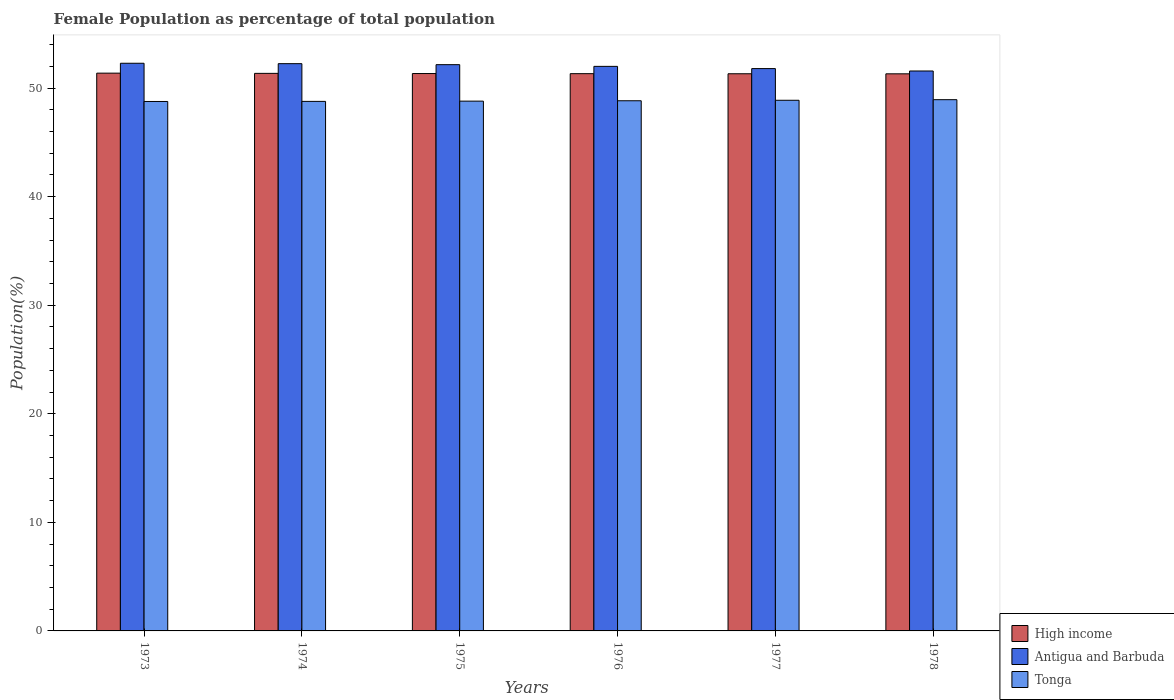How many groups of bars are there?
Give a very brief answer. 6. How many bars are there on the 2nd tick from the left?
Your answer should be compact. 3. What is the label of the 2nd group of bars from the left?
Your answer should be compact. 1974. In how many cases, is the number of bars for a given year not equal to the number of legend labels?
Your answer should be very brief. 0. What is the female population in in High income in 1975?
Provide a succinct answer. 51.34. Across all years, what is the maximum female population in in Antigua and Barbuda?
Give a very brief answer. 52.28. Across all years, what is the minimum female population in in High income?
Ensure brevity in your answer.  51.31. In which year was the female population in in High income maximum?
Make the answer very short. 1973. In which year was the female population in in Tonga minimum?
Give a very brief answer. 1973. What is the total female population in in High income in the graph?
Ensure brevity in your answer.  308.02. What is the difference between the female population in in High income in 1973 and that in 1974?
Ensure brevity in your answer.  0.02. What is the difference between the female population in in Antigua and Barbuda in 1977 and the female population in in Tonga in 1975?
Your answer should be compact. 3. What is the average female population in in Antigua and Barbuda per year?
Keep it short and to the point. 52.01. In the year 1978, what is the difference between the female population in in Antigua and Barbuda and female population in in Tonga?
Ensure brevity in your answer.  2.64. In how many years, is the female population in in Antigua and Barbuda greater than 4 %?
Offer a terse response. 6. What is the ratio of the female population in in Tonga in 1973 to that in 1977?
Your answer should be compact. 1. Is the female population in in High income in 1973 less than that in 1976?
Provide a short and direct response. No. Is the difference between the female population in in Antigua and Barbuda in 1976 and 1978 greater than the difference between the female population in in Tonga in 1976 and 1978?
Give a very brief answer. Yes. What is the difference between the highest and the second highest female population in in High income?
Keep it short and to the point. 0.02. What is the difference between the highest and the lowest female population in in High income?
Keep it short and to the point. 0.06. In how many years, is the female population in in High income greater than the average female population in in High income taken over all years?
Provide a succinct answer. 3. Is the sum of the female population in in Antigua and Barbuda in 1974 and 1978 greater than the maximum female population in in High income across all years?
Ensure brevity in your answer.  Yes. What does the 2nd bar from the left in 1975 represents?
Offer a terse response. Antigua and Barbuda. What does the 2nd bar from the right in 1978 represents?
Ensure brevity in your answer.  Antigua and Barbuda. Is it the case that in every year, the sum of the female population in in Antigua and Barbuda and female population in in Tonga is greater than the female population in in High income?
Provide a succinct answer. Yes. Are the values on the major ticks of Y-axis written in scientific E-notation?
Offer a terse response. No. Does the graph contain any zero values?
Offer a very short reply. No. Does the graph contain grids?
Offer a very short reply. No. Where does the legend appear in the graph?
Ensure brevity in your answer.  Bottom right. How many legend labels are there?
Provide a succinct answer. 3. How are the legend labels stacked?
Your answer should be compact. Vertical. What is the title of the graph?
Ensure brevity in your answer.  Female Population as percentage of total population. Does "Portugal" appear as one of the legend labels in the graph?
Offer a very short reply. No. What is the label or title of the X-axis?
Offer a very short reply. Years. What is the label or title of the Y-axis?
Offer a terse response. Population(%). What is the Population(%) in High income in 1973?
Provide a succinct answer. 51.37. What is the Population(%) of Antigua and Barbuda in 1973?
Ensure brevity in your answer.  52.28. What is the Population(%) of Tonga in 1973?
Make the answer very short. 48.76. What is the Population(%) in High income in 1974?
Keep it short and to the point. 51.35. What is the Population(%) in Antigua and Barbuda in 1974?
Offer a terse response. 52.25. What is the Population(%) of Tonga in 1974?
Your response must be concise. 48.77. What is the Population(%) in High income in 1975?
Offer a terse response. 51.34. What is the Population(%) in Antigua and Barbuda in 1975?
Offer a terse response. 52.16. What is the Population(%) of Tonga in 1975?
Ensure brevity in your answer.  48.8. What is the Population(%) of High income in 1976?
Give a very brief answer. 51.33. What is the Population(%) in Antigua and Barbuda in 1976?
Keep it short and to the point. 52. What is the Population(%) in Tonga in 1976?
Provide a short and direct response. 48.83. What is the Population(%) in High income in 1977?
Keep it short and to the point. 51.32. What is the Population(%) in Antigua and Barbuda in 1977?
Provide a short and direct response. 51.79. What is the Population(%) in Tonga in 1977?
Provide a short and direct response. 48.87. What is the Population(%) in High income in 1978?
Give a very brief answer. 51.31. What is the Population(%) in Antigua and Barbuda in 1978?
Your answer should be compact. 51.57. What is the Population(%) in Tonga in 1978?
Your response must be concise. 48.93. Across all years, what is the maximum Population(%) in High income?
Give a very brief answer. 51.37. Across all years, what is the maximum Population(%) of Antigua and Barbuda?
Offer a terse response. 52.28. Across all years, what is the maximum Population(%) in Tonga?
Provide a short and direct response. 48.93. Across all years, what is the minimum Population(%) of High income?
Provide a short and direct response. 51.31. Across all years, what is the minimum Population(%) in Antigua and Barbuda?
Your answer should be very brief. 51.57. Across all years, what is the minimum Population(%) in Tonga?
Give a very brief answer. 48.76. What is the total Population(%) in High income in the graph?
Give a very brief answer. 308.02. What is the total Population(%) of Antigua and Barbuda in the graph?
Offer a terse response. 312.05. What is the total Population(%) in Tonga in the graph?
Your response must be concise. 292.97. What is the difference between the Population(%) in High income in 1973 and that in 1974?
Provide a succinct answer. 0.02. What is the difference between the Population(%) of Antigua and Barbuda in 1973 and that in 1974?
Offer a very short reply. 0.04. What is the difference between the Population(%) of Tonga in 1973 and that in 1974?
Offer a very short reply. -0.01. What is the difference between the Population(%) in High income in 1973 and that in 1975?
Your response must be concise. 0.04. What is the difference between the Population(%) of Antigua and Barbuda in 1973 and that in 1975?
Offer a terse response. 0.13. What is the difference between the Population(%) of Tonga in 1973 and that in 1975?
Provide a short and direct response. -0.03. What is the difference between the Population(%) of High income in 1973 and that in 1976?
Keep it short and to the point. 0.05. What is the difference between the Population(%) in Antigua and Barbuda in 1973 and that in 1976?
Offer a very short reply. 0.29. What is the difference between the Population(%) of Tonga in 1973 and that in 1976?
Your response must be concise. -0.07. What is the difference between the Population(%) in High income in 1973 and that in 1977?
Keep it short and to the point. 0.06. What is the difference between the Population(%) in Antigua and Barbuda in 1973 and that in 1977?
Offer a very short reply. 0.49. What is the difference between the Population(%) in Tonga in 1973 and that in 1977?
Provide a succinct answer. -0.11. What is the difference between the Population(%) of High income in 1973 and that in 1978?
Your response must be concise. 0.06. What is the difference between the Population(%) in Antigua and Barbuda in 1973 and that in 1978?
Ensure brevity in your answer.  0.71. What is the difference between the Population(%) of Tonga in 1973 and that in 1978?
Offer a very short reply. -0.16. What is the difference between the Population(%) in High income in 1974 and that in 1975?
Make the answer very short. 0.02. What is the difference between the Population(%) in Antigua and Barbuda in 1974 and that in 1975?
Offer a very short reply. 0.09. What is the difference between the Population(%) in Tonga in 1974 and that in 1975?
Your answer should be compact. -0.02. What is the difference between the Population(%) of High income in 1974 and that in 1976?
Your answer should be compact. 0.03. What is the difference between the Population(%) in Antigua and Barbuda in 1974 and that in 1976?
Your response must be concise. 0.25. What is the difference between the Population(%) in Tonga in 1974 and that in 1976?
Keep it short and to the point. -0.06. What is the difference between the Population(%) of High income in 1974 and that in 1977?
Your response must be concise. 0.04. What is the difference between the Population(%) in Antigua and Barbuda in 1974 and that in 1977?
Make the answer very short. 0.45. What is the difference between the Population(%) of Tonga in 1974 and that in 1977?
Keep it short and to the point. -0.1. What is the difference between the Population(%) in High income in 1974 and that in 1978?
Your response must be concise. 0.04. What is the difference between the Population(%) of Antigua and Barbuda in 1974 and that in 1978?
Your answer should be compact. 0.67. What is the difference between the Population(%) of Tonga in 1974 and that in 1978?
Offer a terse response. -0.16. What is the difference between the Population(%) of High income in 1975 and that in 1976?
Your answer should be compact. 0.01. What is the difference between the Population(%) of Antigua and Barbuda in 1975 and that in 1976?
Offer a terse response. 0.16. What is the difference between the Population(%) of Tonga in 1975 and that in 1976?
Your response must be concise. -0.03. What is the difference between the Population(%) in High income in 1975 and that in 1977?
Your answer should be compact. 0.02. What is the difference between the Population(%) of Antigua and Barbuda in 1975 and that in 1977?
Ensure brevity in your answer.  0.36. What is the difference between the Population(%) in Tonga in 1975 and that in 1977?
Provide a short and direct response. -0.08. What is the difference between the Population(%) in High income in 1975 and that in 1978?
Your answer should be compact. 0.03. What is the difference between the Population(%) of Antigua and Barbuda in 1975 and that in 1978?
Provide a short and direct response. 0.58. What is the difference between the Population(%) of Tonga in 1975 and that in 1978?
Offer a very short reply. -0.13. What is the difference between the Population(%) in High income in 1976 and that in 1977?
Offer a terse response. 0.01. What is the difference between the Population(%) in Antigua and Barbuda in 1976 and that in 1977?
Provide a succinct answer. 0.21. What is the difference between the Population(%) of Tonga in 1976 and that in 1977?
Offer a very short reply. -0.04. What is the difference between the Population(%) of High income in 1976 and that in 1978?
Offer a very short reply. 0.01. What is the difference between the Population(%) of Antigua and Barbuda in 1976 and that in 1978?
Your answer should be very brief. 0.43. What is the difference between the Population(%) in Tonga in 1976 and that in 1978?
Give a very brief answer. -0.1. What is the difference between the Population(%) of High income in 1977 and that in 1978?
Keep it short and to the point. 0.01. What is the difference between the Population(%) of Antigua and Barbuda in 1977 and that in 1978?
Make the answer very short. 0.22. What is the difference between the Population(%) in Tonga in 1977 and that in 1978?
Your answer should be compact. -0.05. What is the difference between the Population(%) of High income in 1973 and the Population(%) of Antigua and Barbuda in 1974?
Keep it short and to the point. -0.87. What is the difference between the Population(%) in High income in 1973 and the Population(%) in Tonga in 1974?
Give a very brief answer. 2.6. What is the difference between the Population(%) in Antigua and Barbuda in 1973 and the Population(%) in Tonga in 1974?
Your answer should be compact. 3.51. What is the difference between the Population(%) of High income in 1973 and the Population(%) of Antigua and Barbuda in 1975?
Make the answer very short. -0.78. What is the difference between the Population(%) of High income in 1973 and the Population(%) of Tonga in 1975?
Keep it short and to the point. 2.58. What is the difference between the Population(%) of Antigua and Barbuda in 1973 and the Population(%) of Tonga in 1975?
Ensure brevity in your answer.  3.49. What is the difference between the Population(%) in High income in 1973 and the Population(%) in Antigua and Barbuda in 1976?
Make the answer very short. -0.62. What is the difference between the Population(%) of High income in 1973 and the Population(%) of Tonga in 1976?
Make the answer very short. 2.54. What is the difference between the Population(%) of Antigua and Barbuda in 1973 and the Population(%) of Tonga in 1976?
Provide a succinct answer. 3.45. What is the difference between the Population(%) in High income in 1973 and the Population(%) in Antigua and Barbuda in 1977?
Provide a succinct answer. -0.42. What is the difference between the Population(%) of High income in 1973 and the Population(%) of Tonga in 1977?
Offer a terse response. 2.5. What is the difference between the Population(%) of Antigua and Barbuda in 1973 and the Population(%) of Tonga in 1977?
Offer a terse response. 3.41. What is the difference between the Population(%) in High income in 1973 and the Population(%) in Antigua and Barbuda in 1978?
Make the answer very short. -0.2. What is the difference between the Population(%) in High income in 1973 and the Population(%) in Tonga in 1978?
Make the answer very short. 2.44. What is the difference between the Population(%) of Antigua and Barbuda in 1973 and the Population(%) of Tonga in 1978?
Your response must be concise. 3.36. What is the difference between the Population(%) of High income in 1974 and the Population(%) of Antigua and Barbuda in 1975?
Keep it short and to the point. -0.8. What is the difference between the Population(%) of High income in 1974 and the Population(%) of Tonga in 1975?
Give a very brief answer. 2.56. What is the difference between the Population(%) in Antigua and Barbuda in 1974 and the Population(%) in Tonga in 1975?
Your answer should be very brief. 3.45. What is the difference between the Population(%) in High income in 1974 and the Population(%) in Antigua and Barbuda in 1976?
Your response must be concise. -0.64. What is the difference between the Population(%) of High income in 1974 and the Population(%) of Tonga in 1976?
Provide a short and direct response. 2.52. What is the difference between the Population(%) in Antigua and Barbuda in 1974 and the Population(%) in Tonga in 1976?
Provide a succinct answer. 3.42. What is the difference between the Population(%) in High income in 1974 and the Population(%) in Antigua and Barbuda in 1977?
Provide a succinct answer. -0.44. What is the difference between the Population(%) of High income in 1974 and the Population(%) of Tonga in 1977?
Offer a very short reply. 2.48. What is the difference between the Population(%) in Antigua and Barbuda in 1974 and the Population(%) in Tonga in 1977?
Your answer should be very brief. 3.37. What is the difference between the Population(%) of High income in 1974 and the Population(%) of Antigua and Barbuda in 1978?
Your answer should be compact. -0.22. What is the difference between the Population(%) of High income in 1974 and the Population(%) of Tonga in 1978?
Make the answer very short. 2.42. What is the difference between the Population(%) of Antigua and Barbuda in 1974 and the Population(%) of Tonga in 1978?
Your response must be concise. 3.32. What is the difference between the Population(%) of High income in 1975 and the Population(%) of Antigua and Barbuda in 1976?
Offer a terse response. -0.66. What is the difference between the Population(%) of High income in 1975 and the Population(%) of Tonga in 1976?
Your answer should be compact. 2.51. What is the difference between the Population(%) in Antigua and Barbuda in 1975 and the Population(%) in Tonga in 1976?
Provide a succinct answer. 3.32. What is the difference between the Population(%) of High income in 1975 and the Population(%) of Antigua and Barbuda in 1977?
Offer a terse response. -0.46. What is the difference between the Population(%) of High income in 1975 and the Population(%) of Tonga in 1977?
Your response must be concise. 2.46. What is the difference between the Population(%) in Antigua and Barbuda in 1975 and the Population(%) in Tonga in 1977?
Offer a very short reply. 3.28. What is the difference between the Population(%) of High income in 1975 and the Population(%) of Antigua and Barbuda in 1978?
Keep it short and to the point. -0.24. What is the difference between the Population(%) of High income in 1975 and the Population(%) of Tonga in 1978?
Your response must be concise. 2.41. What is the difference between the Population(%) of Antigua and Barbuda in 1975 and the Population(%) of Tonga in 1978?
Give a very brief answer. 3.23. What is the difference between the Population(%) in High income in 1976 and the Population(%) in Antigua and Barbuda in 1977?
Provide a succinct answer. -0.47. What is the difference between the Population(%) in High income in 1976 and the Population(%) in Tonga in 1977?
Offer a very short reply. 2.45. What is the difference between the Population(%) of Antigua and Barbuda in 1976 and the Population(%) of Tonga in 1977?
Your answer should be very brief. 3.12. What is the difference between the Population(%) in High income in 1976 and the Population(%) in Antigua and Barbuda in 1978?
Provide a succinct answer. -0.25. What is the difference between the Population(%) in High income in 1976 and the Population(%) in Tonga in 1978?
Your response must be concise. 2.4. What is the difference between the Population(%) in Antigua and Barbuda in 1976 and the Population(%) in Tonga in 1978?
Provide a succinct answer. 3.07. What is the difference between the Population(%) in High income in 1977 and the Population(%) in Antigua and Barbuda in 1978?
Give a very brief answer. -0.25. What is the difference between the Population(%) of High income in 1977 and the Population(%) of Tonga in 1978?
Keep it short and to the point. 2.39. What is the difference between the Population(%) of Antigua and Barbuda in 1977 and the Population(%) of Tonga in 1978?
Provide a short and direct response. 2.86. What is the average Population(%) of High income per year?
Give a very brief answer. 51.34. What is the average Population(%) of Antigua and Barbuda per year?
Your answer should be compact. 52.01. What is the average Population(%) of Tonga per year?
Offer a very short reply. 48.83. In the year 1973, what is the difference between the Population(%) in High income and Population(%) in Antigua and Barbuda?
Ensure brevity in your answer.  -0.91. In the year 1973, what is the difference between the Population(%) in High income and Population(%) in Tonga?
Offer a terse response. 2.61. In the year 1973, what is the difference between the Population(%) in Antigua and Barbuda and Population(%) in Tonga?
Keep it short and to the point. 3.52. In the year 1974, what is the difference between the Population(%) of High income and Population(%) of Antigua and Barbuda?
Provide a succinct answer. -0.89. In the year 1974, what is the difference between the Population(%) in High income and Population(%) in Tonga?
Your answer should be compact. 2.58. In the year 1974, what is the difference between the Population(%) of Antigua and Barbuda and Population(%) of Tonga?
Offer a terse response. 3.47. In the year 1975, what is the difference between the Population(%) in High income and Population(%) in Antigua and Barbuda?
Your response must be concise. -0.82. In the year 1975, what is the difference between the Population(%) of High income and Population(%) of Tonga?
Offer a very short reply. 2.54. In the year 1975, what is the difference between the Population(%) in Antigua and Barbuda and Population(%) in Tonga?
Offer a terse response. 3.36. In the year 1976, what is the difference between the Population(%) in High income and Population(%) in Antigua and Barbuda?
Your response must be concise. -0.67. In the year 1976, what is the difference between the Population(%) of High income and Population(%) of Tonga?
Give a very brief answer. 2.5. In the year 1976, what is the difference between the Population(%) in Antigua and Barbuda and Population(%) in Tonga?
Give a very brief answer. 3.17. In the year 1977, what is the difference between the Population(%) in High income and Population(%) in Antigua and Barbuda?
Your response must be concise. -0.48. In the year 1977, what is the difference between the Population(%) of High income and Population(%) of Tonga?
Provide a succinct answer. 2.44. In the year 1977, what is the difference between the Population(%) of Antigua and Barbuda and Population(%) of Tonga?
Your answer should be very brief. 2.92. In the year 1978, what is the difference between the Population(%) in High income and Population(%) in Antigua and Barbuda?
Your response must be concise. -0.26. In the year 1978, what is the difference between the Population(%) in High income and Population(%) in Tonga?
Provide a succinct answer. 2.38. In the year 1978, what is the difference between the Population(%) of Antigua and Barbuda and Population(%) of Tonga?
Provide a succinct answer. 2.64. What is the ratio of the Population(%) in High income in 1973 to that in 1974?
Offer a very short reply. 1. What is the ratio of the Population(%) of Tonga in 1973 to that in 1974?
Ensure brevity in your answer.  1. What is the ratio of the Population(%) in High income in 1973 to that in 1975?
Keep it short and to the point. 1. What is the ratio of the Population(%) in High income in 1973 to that in 1976?
Provide a short and direct response. 1. What is the ratio of the Population(%) in Antigua and Barbuda in 1973 to that in 1976?
Give a very brief answer. 1.01. What is the ratio of the Population(%) of Antigua and Barbuda in 1973 to that in 1977?
Ensure brevity in your answer.  1.01. What is the ratio of the Population(%) in Tonga in 1973 to that in 1977?
Keep it short and to the point. 1. What is the ratio of the Population(%) of High income in 1973 to that in 1978?
Your answer should be very brief. 1. What is the ratio of the Population(%) of Antigua and Barbuda in 1973 to that in 1978?
Your response must be concise. 1.01. What is the ratio of the Population(%) in Tonga in 1974 to that in 1975?
Offer a terse response. 1. What is the ratio of the Population(%) in High income in 1974 to that in 1976?
Keep it short and to the point. 1. What is the ratio of the Population(%) of Tonga in 1974 to that in 1976?
Make the answer very short. 1. What is the ratio of the Population(%) in High income in 1974 to that in 1977?
Keep it short and to the point. 1. What is the ratio of the Population(%) of Antigua and Barbuda in 1974 to that in 1977?
Make the answer very short. 1.01. What is the ratio of the Population(%) of Antigua and Barbuda in 1974 to that in 1978?
Offer a very short reply. 1.01. What is the ratio of the Population(%) of Tonga in 1974 to that in 1978?
Your answer should be very brief. 1. What is the ratio of the Population(%) of High income in 1975 to that in 1976?
Your answer should be compact. 1. What is the ratio of the Population(%) of Antigua and Barbuda in 1975 to that in 1976?
Your answer should be very brief. 1. What is the ratio of the Population(%) of High income in 1975 to that in 1977?
Your response must be concise. 1. What is the ratio of the Population(%) in Tonga in 1975 to that in 1977?
Keep it short and to the point. 1. What is the ratio of the Population(%) of High income in 1975 to that in 1978?
Ensure brevity in your answer.  1. What is the ratio of the Population(%) of Antigua and Barbuda in 1975 to that in 1978?
Offer a very short reply. 1.01. What is the ratio of the Population(%) of Tonga in 1976 to that in 1977?
Your answer should be compact. 1. What is the ratio of the Population(%) of High income in 1976 to that in 1978?
Make the answer very short. 1. What is the ratio of the Population(%) of Antigua and Barbuda in 1976 to that in 1978?
Your answer should be compact. 1.01. What is the ratio of the Population(%) of Tonga in 1976 to that in 1978?
Your answer should be compact. 1. What is the ratio of the Population(%) in Antigua and Barbuda in 1977 to that in 1978?
Provide a short and direct response. 1. What is the ratio of the Population(%) in Tonga in 1977 to that in 1978?
Your response must be concise. 1. What is the difference between the highest and the second highest Population(%) in High income?
Keep it short and to the point. 0.02. What is the difference between the highest and the second highest Population(%) of Antigua and Barbuda?
Provide a succinct answer. 0.04. What is the difference between the highest and the second highest Population(%) of Tonga?
Provide a short and direct response. 0.05. What is the difference between the highest and the lowest Population(%) of High income?
Offer a very short reply. 0.06. What is the difference between the highest and the lowest Population(%) in Antigua and Barbuda?
Your answer should be very brief. 0.71. What is the difference between the highest and the lowest Population(%) in Tonga?
Keep it short and to the point. 0.16. 